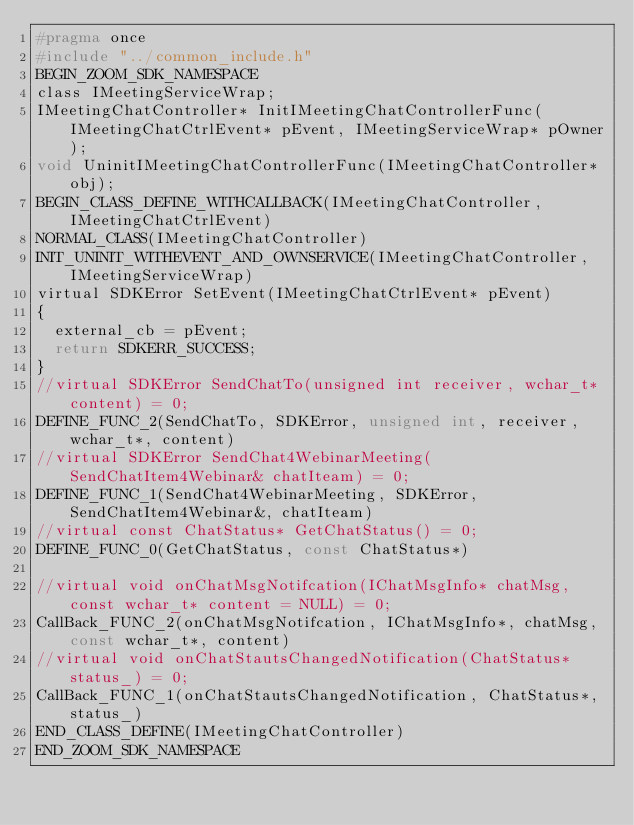Convert code to text. <code><loc_0><loc_0><loc_500><loc_500><_C_>#pragma once
#include "../common_include.h"
BEGIN_ZOOM_SDK_NAMESPACE
class IMeetingServiceWrap;
IMeetingChatController* InitIMeetingChatControllerFunc(IMeetingChatCtrlEvent* pEvent, IMeetingServiceWrap* pOwner);
void UninitIMeetingChatControllerFunc(IMeetingChatController* obj);
BEGIN_CLASS_DEFINE_WITHCALLBACK(IMeetingChatController, IMeetingChatCtrlEvent)
NORMAL_CLASS(IMeetingChatController)
INIT_UNINIT_WITHEVENT_AND_OWNSERVICE(IMeetingChatController, IMeetingServiceWrap)
virtual SDKError SetEvent(IMeetingChatCtrlEvent* pEvent)
{
	external_cb = pEvent;
	return SDKERR_SUCCESS;
}
//virtual SDKError SendChatTo(unsigned int receiver, wchar_t* content) = 0;
DEFINE_FUNC_2(SendChatTo, SDKError, unsigned int, receiver, wchar_t*, content)
//virtual SDKError SendChat4WebinarMeeting(SendChatItem4Webinar& chatIteam) = 0;
DEFINE_FUNC_1(SendChat4WebinarMeeting, SDKError, SendChatItem4Webinar&, chatIteam)
//virtual const ChatStatus* GetChatStatus() = 0;
DEFINE_FUNC_0(GetChatStatus, const ChatStatus*)

//virtual void onChatMsgNotifcation(IChatMsgInfo* chatMsg, const wchar_t* content = NULL) = 0;
CallBack_FUNC_2(onChatMsgNotifcation, IChatMsgInfo*, chatMsg, const wchar_t*, content)
//virtual void onChatStautsChangedNotification(ChatStatus* status_) = 0;
CallBack_FUNC_1(onChatStautsChangedNotification, ChatStatus*, status_)
END_CLASS_DEFINE(IMeetingChatController)
END_ZOOM_SDK_NAMESPACE</code> 